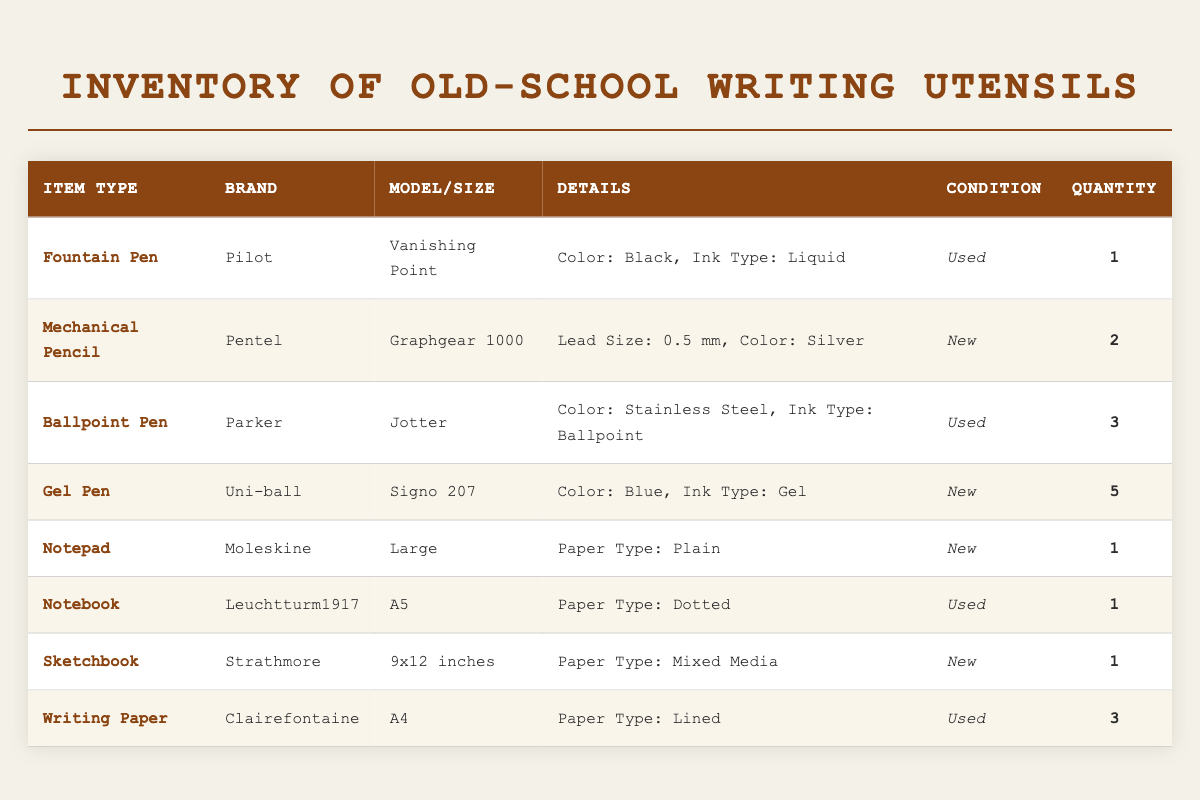What is the total quantity of writing utensils in the inventory? To find the total quantity, we need to sum the quantities of all writing utensils listed in the inventory: 1 (Fountain Pen) + 2 (Mechanical Pencil) + 3 (Ballpoint Pen) + 5 (Gel Pen) = 11. The notepad, notebook, sketchbook, and writing paper are all paper types, so we only consider the quantities from the first four entries. The total of writing utensils is therefore 11.
Answer: 11 Which item has the most quantity available? We will look for the item with the highest quantity in the inventory. From the table: Fountain Pen has 1, Mechanical Pencil has 2, Ballpoint Pen has 3, Gel Pen has 5, and Writing Paper has 3. The Gel Pen from Uni-ball has the highest quantity at 5.
Answer: Gel Pen Is there a new mechanical pencil in the inventory? The mechanical pencil entry specifies it is by Pentel, its model is Graphgear 1000, and its condition is noted as New. Therefore, the statement is true because there is a mechanical pencil that is new.
Answer: Yes How many more ballpoint pens are there than fountain pens? To find the difference in quantity between the ballpoint pen and the fountain pen: Ballpoint Pens (3) - Fountain Pens (1) = 2. Hence, there are 2 more ballpoint pens than fountain pens.
Answer: 2 How many items are in new condition? To determine how many items are new, we will check the condition column in the entire inventory and count the new ones: Mechanical Pencil (New), Gel Pen (New), Notepad (New), Sketchbook (New) for a total of 4 items in new condition.
Answer: 4 How many types of paper are found in the inventory? We examine the "item_type" column, focusing on paper types specifically. The inventory shows Notepad, Notebook, Sketchbook, and Writing Paper. Thus, there are a total of 4 types of paper in the inventory.
Answer: 4 Does the inventory include any used notebooks? According to the table, the only notebook listed is by Leuchtturm1917 and is marked as Used, confirming that there is indeed at least one used notebook in the inventory.
Answer: Yes What is the color of the used fountain pen? The table indicates that the fountain pen, which is a Pilot model Vanishing Point, has a color listed as Black. Therefore, the color of the used fountain pen is Black.
Answer: Black 